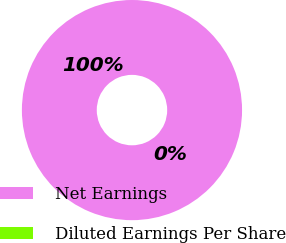Convert chart. <chart><loc_0><loc_0><loc_500><loc_500><pie_chart><fcel>Net Earnings<fcel>Diluted Earnings Per Share<nl><fcel>100.0%<fcel>0.0%<nl></chart> 